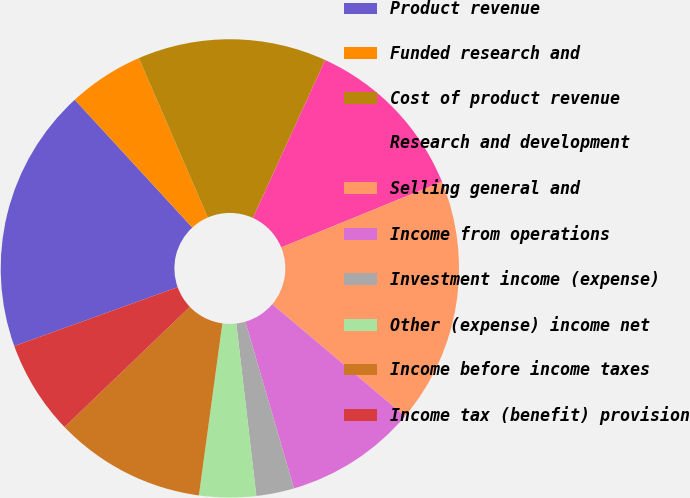<chart> <loc_0><loc_0><loc_500><loc_500><pie_chart><fcel>Product revenue<fcel>Funded research and<fcel>Cost of product revenue<fcel>Research and development<fcel>Selling general and<fcel>Income from operations<fcel>Investment income (expense)<fcel>Other (expense) income net<fcel>Income before income taxes<fcel>Income tax (benefit) provision<nl><fcel>18.67%<fcel>5.33%<fcel>13.33%<fcel>12.0%<fcel>17.33%<fcel>9.33%<fcel>2.67%<fcel>4.0%<fcel>10.67%<fcel>6.67%<nl></chart> 